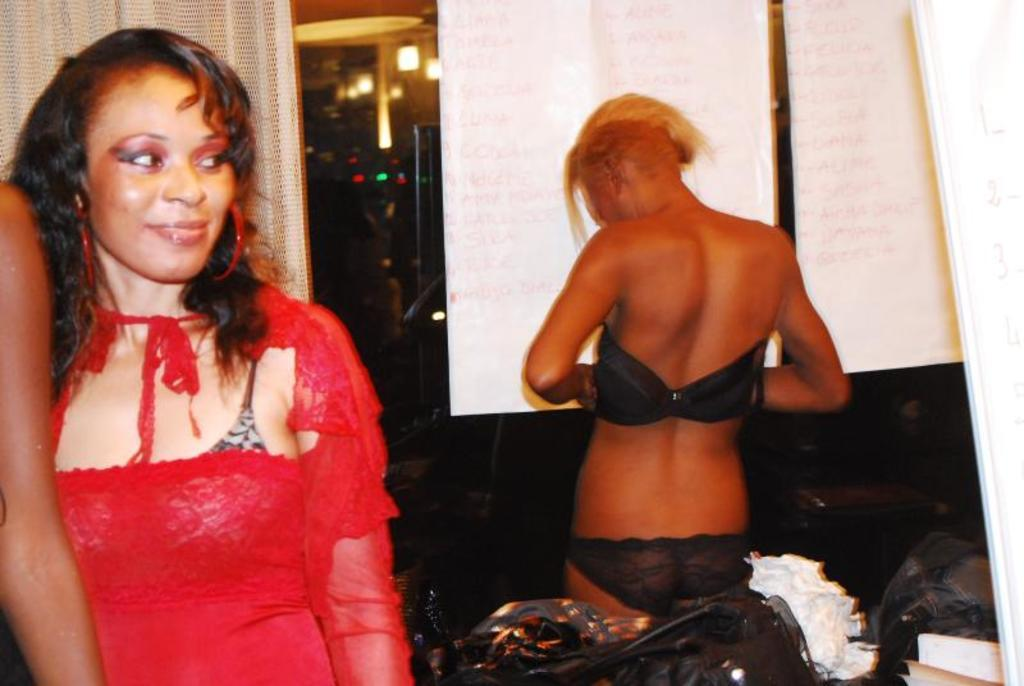How many humans are present in the image? There are two humans in the image. Where is the first human located in the image? One human is on the left side of the image. Where is the second human located in the image? The other human is on the right side of the image. What type of tin is being offered by the human on the right side of the image? There is no tin present in the image, nor is any object being offered by either human. 